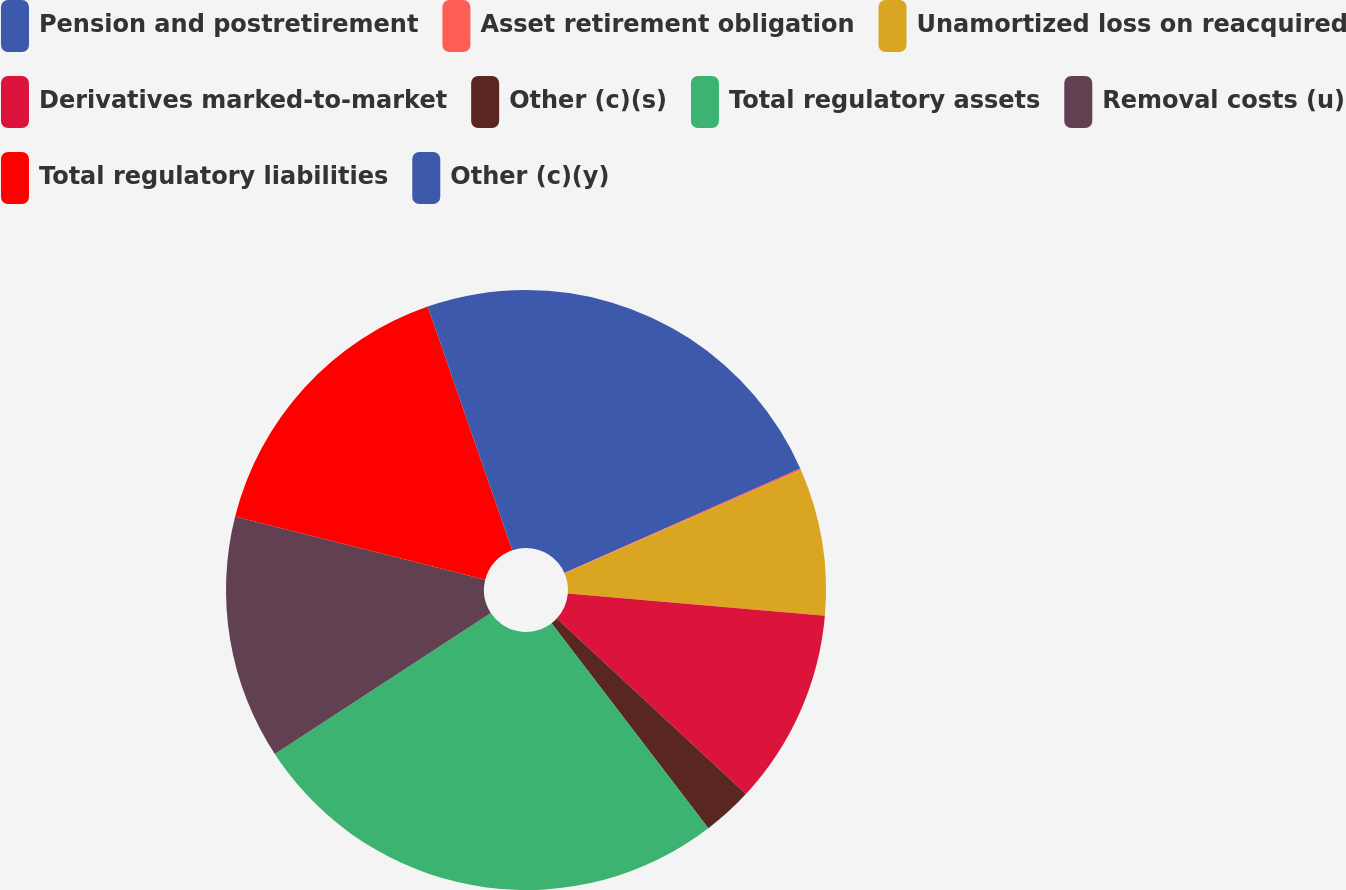<chart> <loc_0><loc_0><loc_500><loc_500><pie_chart><fcel>Pension and postretirement<fcel>Asset retirement obligation<fcel>Unamortized loss on reacquired<fcel>Derivatives marked-to-market<fcel>Other (c)(s)<fcel>Total regulatory assets<fcel>Removal costs (u)<fcel>Total regulatory liabilities<fcel>Other (c)(y)<nl><fcel>18.36%<fcel>0.09%<fcel>7.92%<fcel>10.53%<fcel>2.7%<fcel>26.19%<fcel>13.14%<fcel>15.75%<fcel>5.31%<nl></chart> 